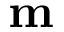Convert formula to latex. <formula><loc_0><loc_0><loc_500><loc_500>m</formula> 